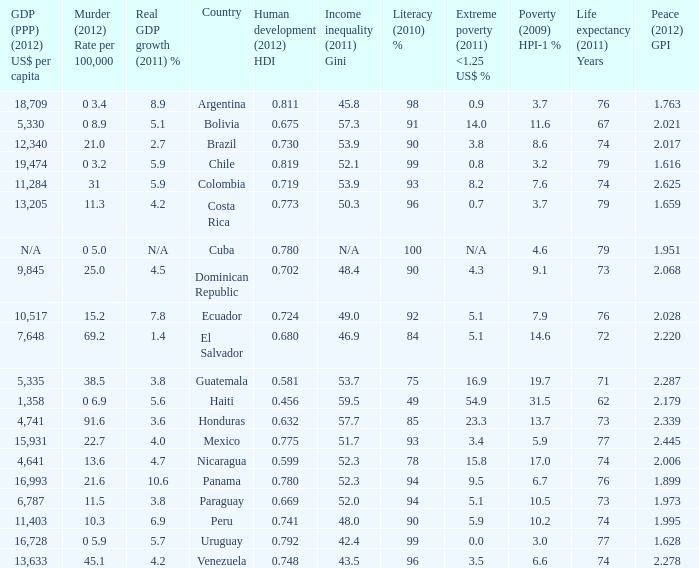What is the total poverty (2009) HPI-1 % when the extreme poverty (2011) <1.25 US$ % of 16.9, and the human development (2012) HDI is less than 0.581? None. 